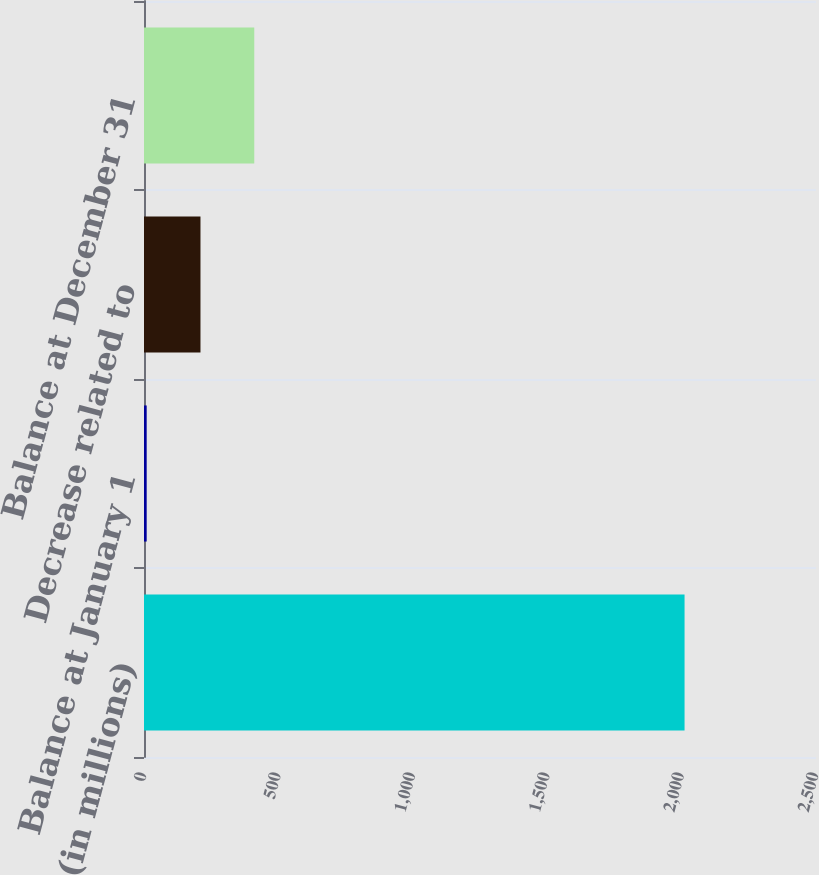Convert chart. <chart><loc_0><loc_0><loc_500><loc_500><bar_chart><fcel>(in millions)<fcel>Balance at January 1<fcel>Decrease related to<fcel>Balance at December 31<nl><fcel>2011<fcel>10<fcel>210.1<fcel>410.2<nl></chart> 